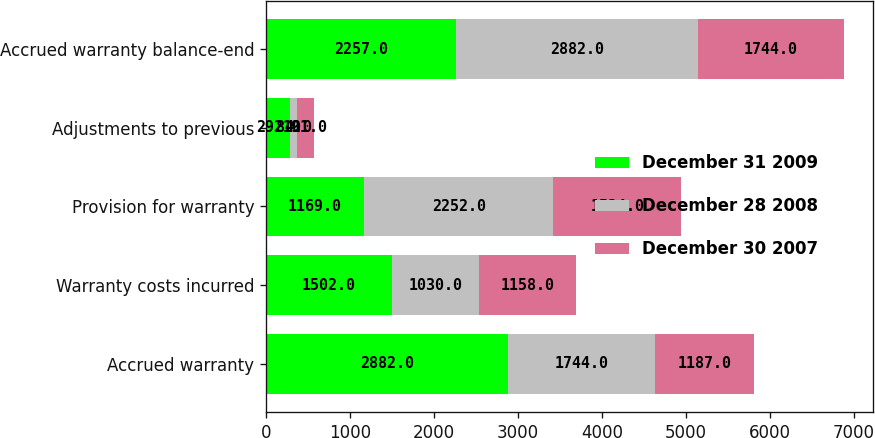<chart> <loc_0><loc_0><loc_500><loc_500><stacked_bar_chart><ecel><fcel>Accrued warranty<fcel>Warranty costs incurred<fcel>Provision for warranty<fcel>Adjustments to previous<fcel>Accrued warranty balance-end<nl><fcel>December 31 2009<fcel>2882<fcel>1502<fcel>1169<fcel>292<fcel>2257<nl><fcel>December 28 2008<fcel>1744<fcel>1030<fcel>2252<fcel>84<fcel>2882<nl><fcel>December 30 2007<fcel>1187<fcel>1158<fcel>1524<fcel>191<fcel>1744<nl></chart> 